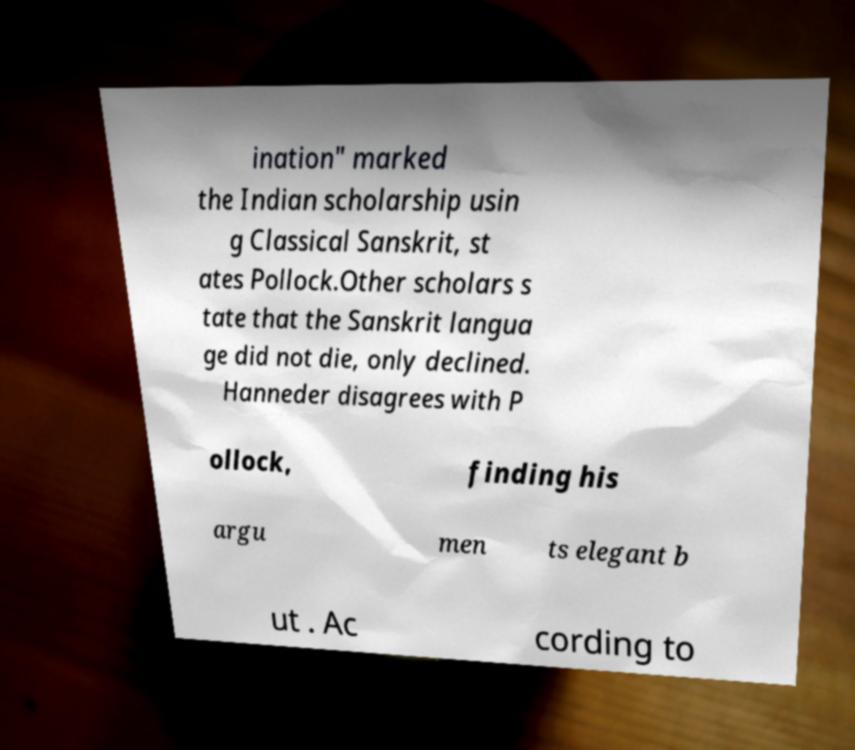Please read and relay the text visible in this image. What does it say? ination" marked the Indian scholarship usin g Classical Sanskrit, st ates Pollock.Other scholars s tate that the Sanskrit langua ge did not die, only declined. Hanneder disagrees with P ollock, finding his argu men ts elegant b ut . Ac cording to 